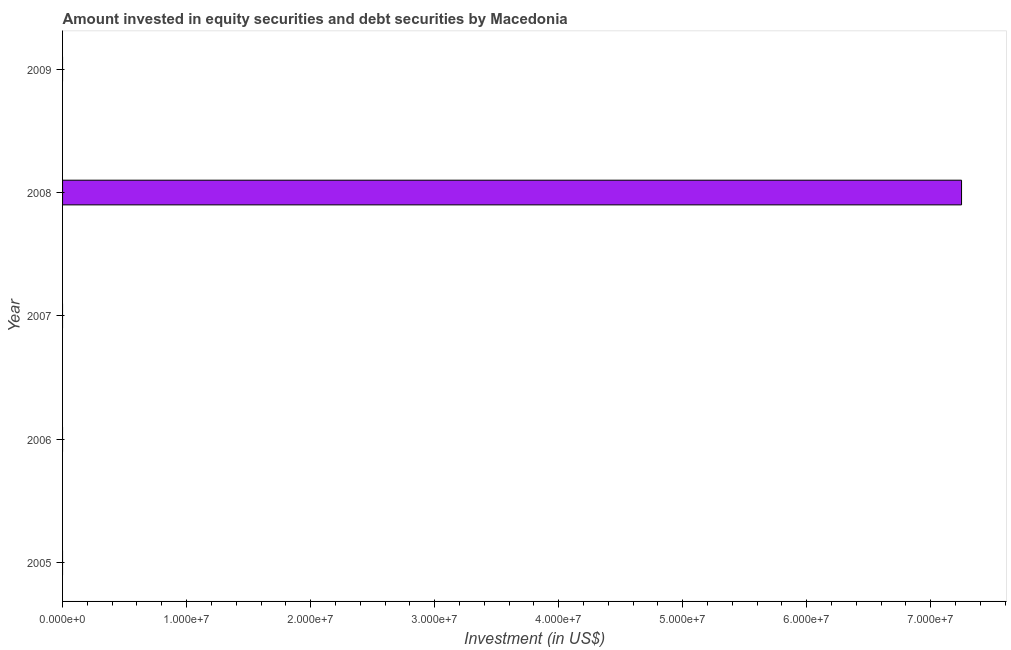Does the graph contain grids?
Provide a succinct answer. No. What is the title of the graph?
Offer a terse response. Amount invested in equity securities and debt securities by Macedonia. What is the label or title of the X-axis?
Offer a terse response. Investment (in US$). Across all years, what is the maximum portfolio investment?
Your answer should be compact. 7.25e+07. Across all years, what is the minimum portfolio investment?
Offer a terse response. 0. In which year was the portfolio investment maximum?
Your response must be concise. 2008. What is the sum of the portfolio investment?
Offer a terse response. 7.25e+07. What is the average portfolio investment per year?
Offer a terse response. 1.45e+07. What is the median portfolio investment?
Your answer should be very brief. 0. In how many years, is the portfolio investment greater than 18000000 US$?
Your response must be concise. 1. What is the difference between the highest and the lowest portfolio investment?
Offer a terse response. 7.25e+07. In how many years, is the portfolio investment greater than the average portfolio investment taken over all years?
Keep it short and to the point. 1. How many bars are there?
Make the answer very short. 1. How many years are there in the graph?
Keep it short and to the point. 5. What is the difference between two consecutive major ticks on the X-axis?
Keep it short and to the point. 1.00e+07. What is the Investment (in US$) in 2007?
Your answer should be very brief. 0. What is the Investment (in US$) in 2008?
Offer a very short reply. 7.25e+07. 